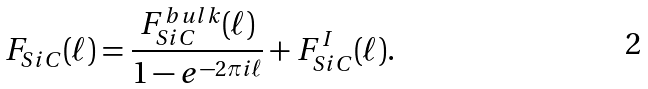<formula> <loc_0><loc_0><loc_500><loc_500>F _ { S i C } ( \ell ) = \frac { F _ { S i C } ^ { b u l k } ( \ell ) } { 1 - e ^ { - 2 \pi { i \ell } } } + F _ { S i C } ^ { I } ( \ell ) .</formula> 